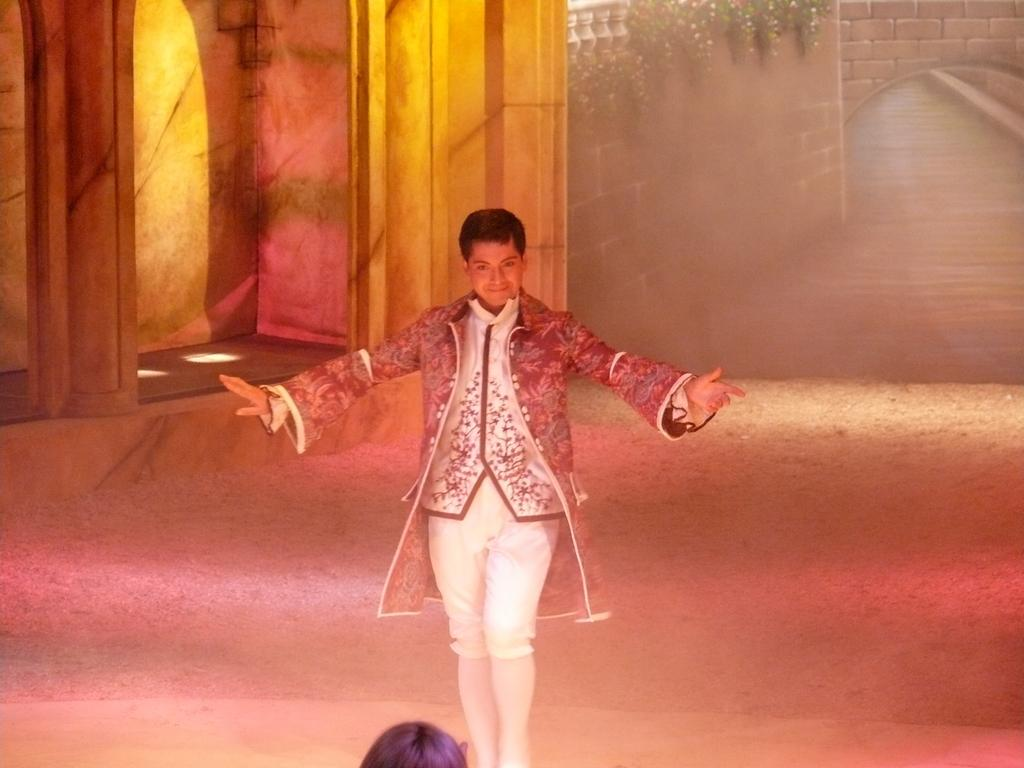How many people are in the image? There are two persons in the image. What is the position of one of the persons? One person is standing. How is the other person depicted in the image? The other person is partially visible (truncated). What architectural features can be seen in the image? There are pillars in the image. What type of vegetation is present in the image? There is a creeper in the image. What type of structure is depicted in the image? There is a wall in the image. Can you tell me how many goats are visible in the image? There are no goats present in the image. What command is given to the person to stop in the image? There is no command given to the person to stop in the image. 